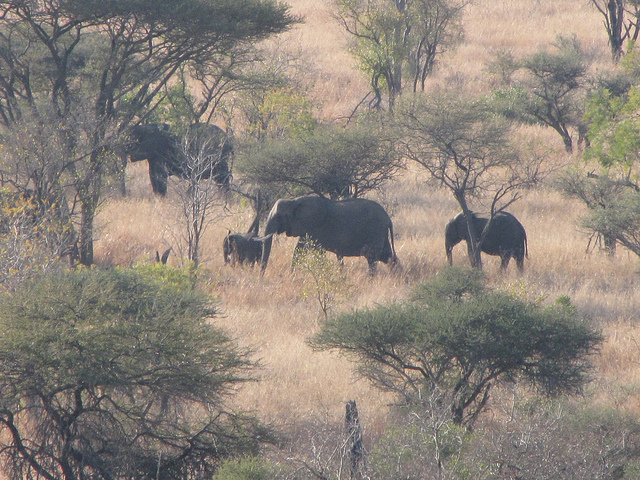<image>What kind of trees are these? I am not sure about the kind of trees. They could possibly be acacia, willows, elm, oak, or pine. What kind of trees are these? I don't know what kind of trees are these. It could be water friendly, acacia, willows, elm, oak, acacia, savannah trees, african, or pine. 